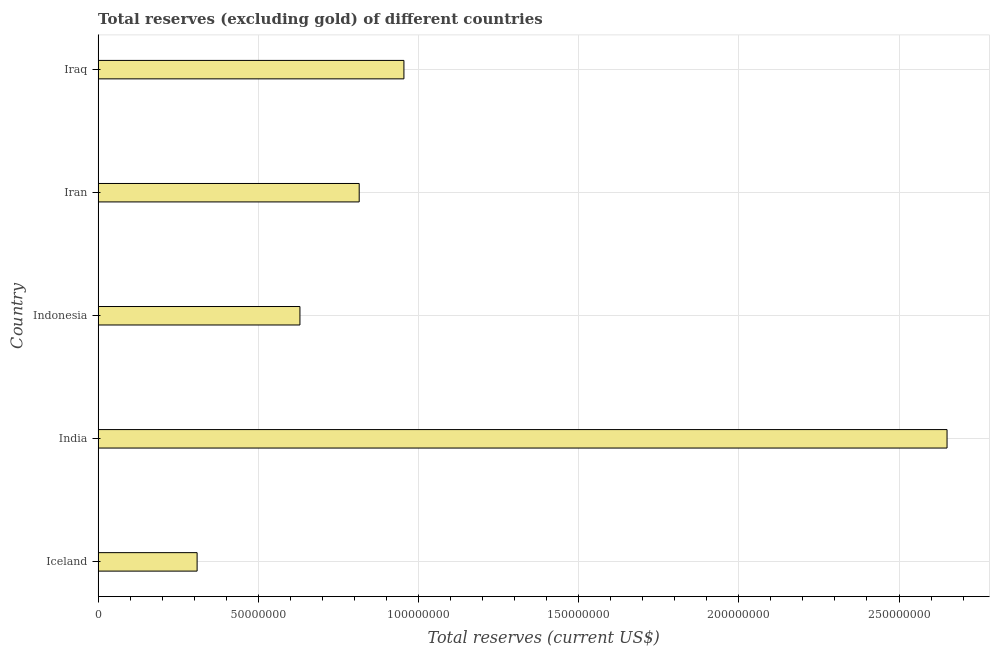What is the title of the graph?
Your response must be concise. Total reserves (excluding gold) of different countries. What is the label or title of the X-axis?
Your response must be concise. Total reserves (current US$). What is the total reserves (excluding gold) in India?
Ensure brevity in your answer.  2.65e+08. Across all countries, what is the maximum total reserves (excluding gold)?
Offer a very short reply. 2.65e+08. Across all countries, what is the minimum total reserves (excluding gold)?
Your response must be concise. 3.09e+07. In which country was the total reserves (excluding gold) minimum?
Your response must be concise. Iceland. What is the sum of the total reserves (excluding gold)?
Keep it short and to the point. 5.36e+08. What is the difference between the total reserves (excluding gold) in India and Iraq?
Give a very brief answer. 1.70e+08. What is the average total reserves (excluding gold) per country?
Offer a very short reply. 1.07e+08. What is the median total reserves (excluding gold)?
Offer a very short reply. 8.15e+07. What is the ratio of the total reserves (excluding gold) in Indonesia to that in Iran?
Keep it short and to the point. 0.77. Is the total reserves (excluding gold) in Indonesia less than that in Iran?
Make the answer very short. Yes. What is the difference between the highest and the second highest total reserves (excluding gold)?
Your response must be concise. 1.70e+08. What is the difference between the highest and the lowest total reserves (excluding gold)?
Your answer should be compact. 2.34e+08. In how many countries, is the total reserves (excluding gold) greater than the average total reserves (excluding gold) taken over all countries?
Provide a short and direct response. 1. How many countries are there in the graph?
Your response must be concise. 5. What is the difference between two consecutive major ticks on the X-axis?
Ensure brevity in your answer.  5.00e+07. What is the Total reserves (current US$) of Iceland?
Ensure brevity in your answer.  3.09e+07. What is the Total reserves (current US$) of India?
Your answer should be compact. 2.65e+08. What is the Total reserves (current US$) of Indonesia?
Keep it short and to the point. 6.30e+07. What is the Total reserves (current US$) in Iran?
Your response must be concise. 8.15e+07. What is the Total reserves (current US$) of Iraq?
Make the answer very short. 9.55e+07. What is the difference between the Total reserves (current US$) in Iceland and India?
Your answer should be compact. -2.34e+08. What is the difference between the Total reserves (current US$) in Iceland and Indonesia?
Offer a very short reply. -3.21e+07. What is the difference between the Total reserves (current US$) in Iceland and Iran?
Give a very brief answer. -5.06e+07. What is the difference between the Total reserves (current US$) in Iceland and Iraq?
Your response must be concise. -6.46e+07. What is the difference between the Total reserves (current US$) in India and Indonesia?
Offer a terse response. 2.02e+08. What is the difference between the Total reserves (current US$) in India and Iran?
Ensure brevity in your answer.  1.84e+08. What is the difference between the Total reserves (current US$) in India and Iraq?
Offer a terse response. 1.70e+08. What is the difference between the Total reserves (current US$) in Indonesia and Iran?
Offer a terse response. -1.85e+07. What is the difference between the Total reserves (current US$) in Indonesia and Iraq?
Your response must be concise. -3.25e+07. What is the difference between the Total reserves (current US$) in Iran and Iraq?
Make the answer very short. -1.40e+07. What is the ratio of the Total reserves (current US$) in Iceland to that in India?
Provide a succinct answer. 0.12. What is the ratio of the Total reserves (current US$) in Iceland to that in Indonesia?
Ensure brevity in your answer.  0.49. What is the ratio of the Total reserves (current US$) in Iceland to that in Iran?
Provide a short and direct response. 0.38. What is the ratio of the Total reserves (current US$) in Iceland to that in Iraq?
Make the answer very short. 0.32. What is the ratio of the Total reserves (current US$) in India to that in Indonesia?
Offer a very short reply. 4.21. What is the ratio of the Total reserves (current US$) in India to that in Iran?
Your answer should be compact. 3.25. What is the ratio of the Total reserves (current US$) in India to that in Iraq?
Ensure brevity in your answer.  2.78. What is the ratio of the Total reserves (current US$) in Indonesia to that in Iran?
Provide a succinct answer. 0.77. What is the ratio of the Total reserves (current US$) in Indonesia to that in Iraq?
Ensure brevity in your answer.  0.66. What is the ratio of the Total reserves (current US$) in Iran to that in Iraq?
Offer a terse response. 0.85. 